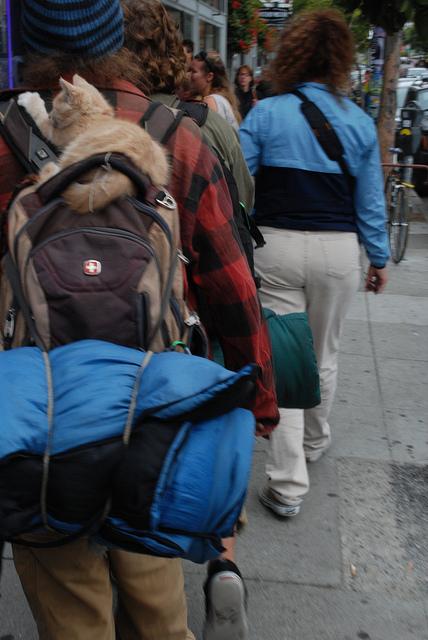What is the object in the foreground?
Be succinct. Backpack. What color is the plaid shirt?
Give a very brief answer. Red and black. What are the people doing?
Write a very short answer. Walking. What is the cat laying on?
Answer briefly. Backpack. 